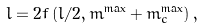<formula> <loc_0><loc_0><loc_500><loc_500>l = 2 f \left ( l / 2 , m ^ { \max } + m _ { c } ^ { \max } \right ) ,</formula> 